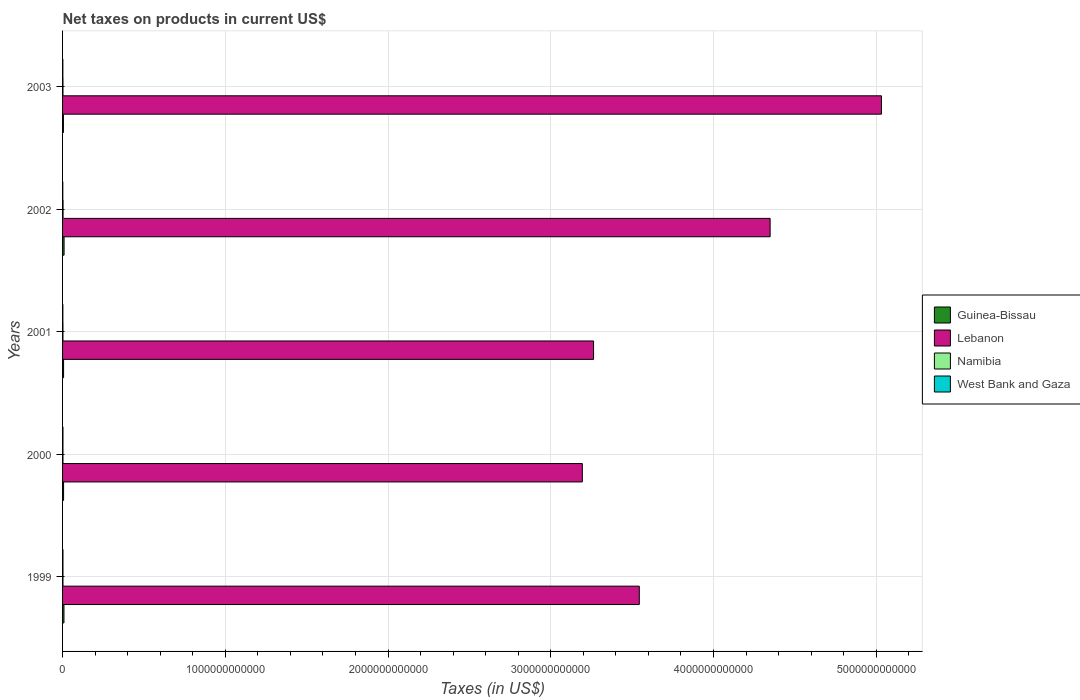How many different coloured bars are there?
Provide a succinct answer. 4. Are the number of bars per tick equal to the number of legend labels?
Your response must be concise. Yes. Are the number of bars on each tick of the Y-axis equal?
Offer a terse response. Yes. How many bars are there on the 2nd tick from the top?
Your response must be concise. 4. What is the label of the 4th group of bars from the top?
Make the answer very short. 2000. In how many cases, is the number of bars for a given year not equal to the number of legend labels?
Keep it short and to the point. 0. What is the net taxes on products in Guinea-Bissau in 2000?
Offer a terse response. 6.22e+09. Across all years, what is the maximum net taxes on products in Guinea-Bissau?
Your answer should be compact. 9.26e+09. Across all years, what is the minimum net taxes on products in Guinea-Bissau?
Make the answer very short. 5.26e+09. In which year was the net taxes on products in Namibia maximum?
Provide a succinct answer. 2002. In which year was the net taxes on products in West Bank and Gaza minimum?
Ensure brevity in your answer.  2002. What is the total net taxes on products in Namibia in the graph?
Offer a very short reply. 1.28e+1. What is the difference between the net taxes on products in West Bank and Gaza in 1999 and that in 2001?
Your answer should be very brief. 6.87e+08. What is the difference between the net taxes on products in Guinea-Bissau in 2000 and the net taxes on products in West Bank and Gaza in 2003?
Provide a succinct answer. 4.45e+09. What is the average net taxes on products in Lebanon per year?
Provide a short and direct response. 3.88e+12. In the year 1999, what is the difference between the net taxes on products in Namibia and net taxes on products in Guinea-Bissau?
Provide a short and direct response. -6.15e+09. In how many years, is the net taxes on products in Lebanon greater than 4400000000000 US$?
Offer a very short reply. 1. What is the ratio of the net taxes on products in Namibia in 1999 to that in 2003?
Provide a short and direct response. 0.98. What is the difference between the highest and the second highest net taxes on products in Namibia?
Your answer should be very brief. 5.33e+08. What is the difference between the highest and the lowest net taxes on products in Lebanon?
Give a very brief answer. 1.84e+12. Is the sum of the net taxes on products in Guinea-Bissau in 1999 and 2000 greater than the maximum net taxes on products in Lebanon across all years?
Your answer should be compact. No. What does the 3rd bar from the top in 2002 represents?
Provide a succinct answer. Lebanon. What does the 2nd bar from the bottom in 2002 represents?
Provide a short and direct response. Lebanon. How many bars are there?
Keep it short and to the point. 20. Are all the bars in the graph horizontal?
Ensure brevity in your answer.  Yes. What is the difference between two consecutive major ticks on the X-axis?
Your answer should be very brief. 1.00e+12. Are the values on the major ticks of X-axis written in scientific E-notation?
Your answer should be very brief. No. Does the graph contain any zero values?
Make the answer very short. No. Where does the legend appear in the graph?
Your answer should be very brief. Center right. How many legend labels are there?
Ensure brevity in your answer.  4. What is the title of the graph?
Keep it short and to the point. Net taxes on products in current US$. Does "Brazil" appear as one of the legend labels in the graph?
Provide a short and direct response. No. What is the label or title of the X-axis?
Provide a succinct answer. Taxes (in US$). What is the Taxes (in US$) in Guinea-Bissau in 1999?
Your answer should be compact. 8.60e+09. What is the Taxes (in US$) of Lebanon in 1999?
Give a very brief answer. 3.54e+12. What is the Taxes (in US$) in Namibia in 1999?
Your answer should be compact. 2.45e+09. What is the Taxes (in US$) in West Bank and Gaza in 1999?
Offer a very short reply. 2.48e+09. What is the Taxes (in US$) in Guinea-Bissau in 2000?
Ensure brevity in your answer.  6.22e+09. What is the Taxes (in US$) of Lebanon in 2000?
Make the answer very short. 3.19e+12. What is the Taxes (in US$) in Namibia in 2000?
Offer a very short reply. 2.42e+09. What is the Taxes (in US$) of West Bank and Gaza in 2000?
Ensure brevity in your answer.  2.44e+09. What is the Taxes (in US$) in Guinea-Bissau in 2001?
Offer a terse response. 6.26e+09. What is the Taxes (in US$) of Lebanon in 2001?
Provide a succinct answer. 3.26e+12. What is the Taxes (in US$) in Namibia in 2001?
Your answer should be very brief. 2.35e+09. What is the Taxes (in US$) of West Bank and Gaza in 2001?
Your answer should be compact. 1.79e+09. What is the Taxes (in US$) of Guinea-Bissau in 2002?
Your answer should be very brief. 9.26e+09. What is the Taxes (in US$) in Lebanon in 2002?
Provide a short and direct response. 4.35e+12. What is the Taxes (in US$) of Namibia in 2002?
Make the answer very short. 3.04e+09. What is the Taxes (in US$) of West Bank and Gaza in 2002?
Your response must be concise. 1.42e+09. What is the Taxes (in US$) of Guinea-Bissau in 2003?
Your answer should be very brief. 5.26e+09. What is the Taxes (in US$) of Lebanon in 2003?
Provide a short and direct response. 5.03e+12. What is the Taxes (in US$) in Namibia in 2003?
Ensure brevity in your answer.  2.51e+09. What is the Taxes (in US$) of West Bank and Gaza in 2003?
Provide a succinct answer. 1.77e+09. Across all years, what is the maximum Taxes (in US$) of Guinea-Bissau?
Your answer should be very brief. 9.26e+09. Across all years, what is the maximum Taxes (in US$) in Lebanon?
Give a very brief answer. 5.03e+12. Across all years, what is the maximum Taxes (in US$) in Namibia?
Provide a short and direct response. 3.04e+09. Across all years, what is the maximum Taxes (in US$) in West Bank and Gaza?
Make the answer very short. 2.48e+09. Across all years, what is the minimum Taxes (in US$) of Guinea-Bissau?
Offer a very short reply. 5.26e+09. Across all years, what is the minimum Taxes (in US$) of Lebanon?
Provide a succinct answer. 3.19e+12. Across all years, what is the minimum Taxes (in US$) in Namibia?
Provide a short and direct response. 2.35e+09. Across all years, what is the minimum Taxes (in US$) in West Bank and Gaza?
Provide a short and direct response. 1.42e+09. What is the total Taxes (in US$) of Guinea-Bissau in the graph?
Your answer should be very brief. 3.56e+1. What is the total Taxes (in US$) in Lebanon in the graph?
Your answer should be very brief. 1.94e+13. What is the total Taxes (in US$) of Namibia in the graph?
Offer a terse response. 1.28e+1. What is the total Taxes (in US$) of West Bank and Gaza in the graph?
Offer a very short reply. 9.90e+09. What is the difference between the Taxes (in US$) in Guinea-Bissau in 1999 and that in 2000?
Ensure brevity in your answer.  2.38e+09. What is the difference between the Taxes (in US$) of Lebanon in 1999 and that in 2000?
Your answer should be very brief. 3.50e+11. What is the difference between the Taxes (in US$) of Namibia in 1999 and that in 2000?
Your answer should be very brief. 3.20e+07. What is the difference between the Taxes (in US$) of West Bank and Gaza in 1999 and that in 2000?
Offer a terse response. 3.80e+07. What is the difference between the Taxes (in US$) of Guinea-Bissau in 1999 and that in 2001?
Your answer should be very brief. 2.34e+09. What is the difference between the Taxes (in US$) of Lebanon in 1999 and that in 2001?
Provide a short and direct response. 2.81e+11. What is the difference between the Taxes (in US$) of Namibia in 1999 and that in 2001?
Offer a very short reply. 9.98e+07. What is the difference between the Taxes (in US$) of West Bank and Gaza in 1999 and that in 2001?
Provide a succinct answer. 6.87e+08. What is the difference between the Taxes (in US$) of Guinea-Bissau in 1999 and that in 2002?
Offer a terse response. -6.60e+08. What is the difference between the Taxes (in US$) in Lebanon in 1999 and that in 2002?
Offer a very short reply. -8.04e+11. What is the difference between the Taxes (in US$) in Namibia in 1999 and that in 2002?
Keep it short and to the point. -5.86e+08. What is the difference between the Taxes (in US$) in West Bank and Gaza in 1999 and that in 2002?
Your response must be concise. 1.06e+09. What is the difference between the Taxes (in US$) of Guinea-Bissau in 1999 and that in 2003?
Offer a terse response. 3.34e+09. What is the difference between the Taxes (in US$) of Lebanon in 1999 and that in 2003?
Your answer should be compact. -1.49e+12. What is the difference between the Taxes (in US$) in Namibia in 1999 and that in 2003?
Offer a terse response. -5.29e+07. What is the difference between the Taxes (in US$) of West Bank and Gaza in 1999 and that in 2003?
Your answer should be compact. 7.06e+08. What is the difference between the Taxes (in US$) of Guinea-Bissau in 2000 and that in 2001?
Make the answer very short. -3.80e+07. What is the difference between the Taxes (in US$) of Lebanon in 2000 and that in 2001?
Make the answer very short. -6.90e+1. What is the difference between the Taxes (in US$) in Namibia in 2000 and that in 2001?
Provide a succinct answer. 6.79e+07. What is the difference between the Taxes (in US$) in West Bank and Gaza in 2000 and that in 2001?
Your answer should be very brief. 6.49e+08. What is the difference between the Taxes (in US$) of Guinea-Bissau in 2000 and that in 2002?
Your answer should be very brief. -3.04e+09. What is the difference between the Taxes (in US$) of Lebanon in 2000 and that in 2002?
Ensure brevity in your answer.  -1.15e+12. What is the difference between the Taxes (in US$) in Namibia in 2000 and that in 2002?
Give a very brief answer. -6.18e+08. What is the difference between the Taxes (in US$) in West Bank and Gaza in 2000 and that in 2002?
Provide a short and direct response. 1.02e+09. What is the difference between the Taxes (in US$) in Guinea-Bissau in 2000 and that in 2003?
Ensure brevity in your answer.  9.61e+08. What is the difference between the Taxes (in US$) in Lebanon in 2000 and that in 2003?
Make the answer very short. -1.84e+12. What is the difference between the Taxes (in US$) of Namibia in 2000 and that in 2003?
Keep it short and to the point. -8.48e+07. What is the difference between the Taxes (in US$) of West Bank and Gaza in 2000 and that in 2003?
Your answer should be compact. 6.68e+08. What is the difference between the Taxes (in US$) of Guinea-Bissau in 2001 and that in 2002?
Your answer should be very brief. -3.00e+09. What is the difference between the Taxes (in US$) in Lebanon in 2001 and that in 2002?
Provide a short and direct response. -1.08e+12. What is the difference between the Taxes (in US$) in Namibia in 2001 and that in 2002?
Give a very brief answer. -6.85e+08. What is the difference between the Taxes (in US$) in West Bank and Gaza in 2001 and that in 2002?
Make the answer very short. 3.75e+08. What is the difference between the Taxes (in US$) of Guinea-Bissau in 2001 and that in 2003?
Provide a short and direct response. 9.99e+08. What is the difference between the Taxes (in US$) in Lebanon in 2001 and that in 2003?
Provide a short and direct response. -1.77e+12. What is the difference between the Taxes (in US$) of Namibia in 2001 and that in 2003?
Your response must be concise. -1.53e+08. What is the difference between the Taxes (in US$) in West Bank and Gaza in 2001 and that in 2003?
Give a very brief answer. 1.85e+07. What is the difference between the Taxes (in US$) in Guinea-Bissau in 2002 and that in 2003?
Ensure brevity in your answer.  4.00e+09. What is the difference between the Taxes (in US$) of Lebanon in 2002 and that in 2003?
Ensure brevity in your answer.  -6.84e+11. What is the difference between the Taxes (in US$) of Namibia in 2002 and that in 2003?
Your answer should be very brief. 5.33e+08. What is the difference between the Taxes (in US$) of West Bank and Gaza in 2002 and that in 2003?
Offer a very short reply. -3.56e+08. What is the difference between the Taxes (in US$) of Guinea-Bissau in 1999 and the Taxes (in US$) of Lebanon in 2000?
Offer a very short reply. -3.19e+12. What is the difference between the Taxes (in US$) of Guinea-Bissau in 1999 and the Taxes (in US$) of Namibia in 2000?
Keep it short and to the point. 6.18e+09. What is the difference between the Taxes (in US$) in Guinea-Bissau in 1999 and the Taxes (in US$) in West Bank and Gaza in 2000?
Your answer should be compact. 6.16e+09. What is the difference between the Taxes (in US$) of Lebanon in 1999 and the Taxes (in US$) of Namibia in 2000?
Provide a succinct answer. 3.54e+12. What is the difference between the Taxes (in US$) in Lebanon in 1999 and the Taxes (in US$) in West Bank and Gaza in 2000?
Offer a very short reply. 3.54e+12. What is the difference between the Taxes (in US$) of Namibia in 1999 and the Taxes (in US$) of West Bank and Gaza in 2000?
Keep it short and to the point. 1.24e+07. What is the difference between the Taxes (in US$) of Guinea-Bissau in 1999 and the Taxes (in US$) of Lebanon in 2001?
Ensure brevity in your answer.  -3.25e+12. What is the difference between the Taxes (in US$) of Guinea-Bissau in 1999 and the Taxes (in US$) of Namibia in 2001?
Provide a short and direct response. 6.25e+09. What is the difference between the Taxes (in US$) of Guinea-Bissau in 1999 and the Taxes (in US$) of West Bank and Gaza in 2001?
Provide a short and direct response. 6.81e+09. What is the difference between the Taxes (in US$) of Lebanon in 1999 and the Taxes (in US$) of Namibia in 2001?
Make the answer very short. 3.54e+12. What is the difference between the Taxes (in US$) in Lebanon in 1999 and the Taxes (in US$) in West Bank and Gaza in 2001?
Provide a short and direct response. 3.54e+12. What is the difference between the Taxes (in US$) in Namibia in 1999 and the Taxes (in US$) in West Bank and Gaza in 2001?
Your answer should be compact. 6.62e+08. What is the difference between the Taxes (in US$) of Guinea-Bissau in 1999 and the Taxes (in US$) of Lebanon in 2002?
Your response must be concise. -4.34e+12. What is the difference between the Taxes (in US$) in Guinea-Bissau in 1999 and the Taxes (in US$) in Namibia in 2002?
Your response must be concise. 5.56e+09. What is the difference between the Taxes (in US$) in Guinea-Bissau in 1999 and the Taxes (in US$) in West Bank and Gaza in 2002?
Offer a very short reply. 7.18e+09. What is the difference between the Taxes (in US$) of Lebanon in 1999 and the Taxes (in US$) of Namibia in 2002?
Give a very brief answer. 3.54e+12. What is the difference between the Taxes (in US$) of Lebanon in 1999 and the Taxes (in US$) of West Bank and Gaza in 2002?
Offer a terse response. 3.54e+12. What is the difference between the Taxes (in US$) in Namibia in 1999 and the Taxes (in US$) in West Bank and Gaza in 2002?
Provide a succinct answer. 1.04e+09. What is the difference between the Taxes (in US$) in Guinea-Bissau in 1999 and the Taxes (in US$) in Lebanon in 2003?
Give a very brief answer. -5.02e+12. What is the difference between the Taxes (in US$) in Guinea-Bissau in 1999 and the Taxes (in US$) in Namibia in 2003?
Give a very brief answer. 6.09e+09. What is the difference between the Taxes (in US$) of Guinea-Bissau in 1999 and the Taxes (in US$) of West Bank and Gaza in 2003?
Offer a terse response. 6.83e+09. What is the difference between the Taxes (in US$) of Lebanon in 1999 and the Taxes (in US$) of Namibia in 2003?
Your answer should be very brief. 3.54e+12. What is the difference between the Taxes (in US$) of Lebanon in 1999 and the Taxes (in US$) of West Bank and Gaza in 2003?
Provide a short and direct response. 3.54e+12. What is the difference between the Taxes (in US$) in Namibia in 1999 and the Taxes (in US$) in West Bank and Gaza in 2003?
Provide a short and direct response. 6.80e+08. What is the difference between the Taxes (in US$) of Guinea-Bissau in 2000 and the Taxes (in US$) of Lebanon in 2001?
Your answer should be very brief. -3.26e+12. What is the difference between the Taxes (in US$) in Guinea-Bissau in 2000 and the Taxes (in US$) in Namibia in 2001?
Your answer should be compact. 3.87e+09. What is the difference between the Taxes (in US$) in Guinea-Bissau in 2000 and the Taxes (in US$) in West Bank and Gaza in 2001?
Provide a succinct answer. 4.43e+09. What is the difference between the Taxes (in US$) of Lebanon in 2000 and the Taxes (in US$) of Namibia in 2001?
Keep it short and to the point. 3.19e+12. What is the difference between the Taxes (in US$) in Lebanon in 2000 and the Taxes (in US$) in West Bank and Gaza in 2001?
Offer a very short reply. 3.19e+12. What is the difference between the Taxes (in US$) in Namibia in 2000 and the Taxes (in US$) in West Bank and Gaza in 2001?
Your answer should be compact. 6.30e+08. What is the difference between the Taxes (in US$) in Guinea-Bissau in 2000 and the Taxes (in US$) in Lebanon in 2002?
Offer a terse response. -4.34e+12. What is the difference between the Taxes (in US$) of Guinea-Bissau in 2000 and the Taxes (in US$) of Namibia in 2002?
Provide a succinct answer. 3.19e+09. What is the difference between the Taxes (in US$) of Guinea-Bissau in 2000 and the Taxes (in US$) of West Bank and Gaza in 2002?
Offer a very short reply. 4.81e+09. What is the difference between the Taxes (in US$) in Lebanon in 2000 and the Taxes (in US$) in Namibia in 2002?
Keep it short and to the point. 3.19e+12. What is the difference between the Taxes (in US$) in Lebanon in 2000 and the Taxes (in US$) in West Bank and Gaza in 2002?
Provide a succinct answer. 3.19e+12. What is the difference between the Taxes (in US$) of Namibia in 2000 and the Taxes (in US$) of West Bank and Gaza in 2002?
Offer a very short reply. 1.00e+09. What is the difference between the Taxes (in US$) in Guinea-Bissau in 2000 and the Taxes (in US$) in Lebanon in 2003?
Your answer should be compact. -5.03e+12. What is the difference between the Taxes (in US$) in Guinea-Bissau in 2000 and the Taxes (in US$) in Namibia in 2003?
Offer a very short reply. 3.72e+09. What is the difference between the Taxes (in US$) in Guinea-Bissau in 2000 and the Taxes (in US$) in West Bank and Gaza in 2003?
Give a very brief answer. 4.45e+09. What is the difference between the Taxes (in US$) in Lebanon in 2000 and the Taxes (in US$) in Namibia in 2003?
Your answer should be compact. 3.19e+12. What is the difference between the Taxes (in US$) in Lebanon in 2000 and the Taxes (in US$) in West Bank and Gaza in 2003?
Your answer should be compact. 3.19e+12. What is the difference between the Taxes (in US$) in Namibia in 2000 and the Taxes (in US$) in West Bank and Gaza in 2003?
Your answer should be very brief. 6.48e+08. What is the difference between the Taxes (in US$) in Guinea-Bissau in 2001 and the Taxes (in US$) in Lebanon in 2002?
Your response must be concise. -4.34e+12. What is the difference between the Taxes (in US$) in Guinea-Bissau in 2001 and the Taxes (in US$) in Namibia in 2002?
Offer a very short reply. 3.22e+09. What is the difference between the Taxes (in US$) of Guinea-Bissau in 2001 and the Taxes (in US$) of West Bank and Gaza in 2002?
Keep it short and to the point. 4.85e+09. What is the difference between the Taxes (in US$) of Lebanon in 2001 and the Taxes (in US$) of Namibia in 2002?
Provide a succinct answer. 3.26e+12. What is the difference between the Taxes (in US$) of Lebanon in 2001 and the Taxes (in US$) of West Bank and Gaza in 2002?
Your answer should be very brief. 3.26e+12. What is the difference between the Taxes (in US$) in Namibia in 2001 and the Taxes (in US$) in West Bank and Gaza in 2002?
Make the answer very short. 9.36e+08. What is the difference between the Taxes (in US$) in Guinea-Bissau in 2001 and the Taxes (in US$) in Lebanon in 2003?
Give a very brief answer. -5.03e+12. What is the difference between the Taxes (in US$) of Guinea-Bissau in 2001 and the Taxes (in US$) of Namibia in 2003?
Give a very brief answer. 3.76e+09. What is the difference between the Taxes (in US$) of Guinea-Bissau in 2001 and the Taxes (in US$) of West Bank and Gaza in 2003?
Your response must be concise. 4.49e+09. What is the difference between the Taxes (in US$) of Lebanon in 2001 and the Taxes (in US$) of Namibia in 2003?
Your response must be concise. 3.26e+12. What is the difference between the Taxes (in US$) in Lebanon in 2001 and the Taxes (in US$) in West Bank and Gaza in 2003?
Give a very brief answer. 3.26e+12. What is the difference between the Taxes (in US$) of Namibia in 2001 and the Taxes (in US$) of West Bank and Gaza in 2003?
Give a very brief answer. 5.80e+08. What is the difference between the Taxes (in US$) in Guinea-Bissau in 2002 and the Taxes (in US$) in Lebanon in 2003?
Ensure brevity in your answer.  -5.02e+12. What is the difference between the Taxes (in US$) of Guinea-Bissau in 2002 and the Taxes (in US$) of Namibia in 2003?
Offer a very short reply. 6.75e+09. What is the difference between the Taxes (in US$) in Guinea-Bissau in 2002 and the Taxes (in US$) in West Bank and Gaza in 2003?
Offer a terse response. 7.49e+09. What is the difference between the Taxes (in US$) in Lebanon in 2002 and the Taxes (in US$) in Namibia in 2003?
Provide a succinct answer. 4.35e+12. What is the difference between the Taxes (in US$) in Lebanon in 2002 and the Taxes (in US$) in West Bank and Gaza in 2003?
Ensure brevity in your answer.  4.35e+12. What is the difference between the Taxes (in US$) of Namibia in 2002 and the Taxes (in US$) of West Bank and Gaza in 2003?
Offer a terse response. 1.27e+09. What is the average Taxes (in US$) of Guinea-Bissau per year?
Your answer should be very brief. 7.12e+09. What is the average Taxes (in US$) of Lebanon per year?
Keep it short and to the point. 3.88e+12. What is the average Taxes (in US$) of Namibia per year?
Give a very brief answer. 2.55e+09. What is the average Taxes (in US$) in West Bank and Gaza per year?
Keep it short and to the point. 1.98e+09. In the year 1999, what is the difference between the Taxes (in US$) of Guinea-Bissau and Taxes (in US$) of Lebanon?
Your answer should be compact. -3.54e+12. In the year 1999, what is the difference between the Taxes (in US$) of Guinea-Bissau and Taxes (in US$) of Namibia?
Offer a very short reply. 6.15e+09. In the year 1999, what is the difference between the Taxes (in US$) of Guinea-Bissau and Taxes (in US$) of West Bank and Gaza?
Your response must be concise. 6.12e+09. In the year 1999, what is the difference between the Taxes (in US$) of Lebanon and Taxes (in US$) of Namibia?
Provide a short and direct response. 3.54e+12. In the year 1999, what is the difference between the Taxes (in US$) of Lebanon and Taxes (in US$) of West Bank and Gaza?
Make the answer very short. 3.54e+12. In the year 1999, what is the difference between the Taxes (in US$) in Namibia and Taxes (in US$) in West Bank and Gaza?
Offer a terse response. -2.56e+07. In the year 2000, what is the difference between the Taxes (in US$) in Guinea-Bissau and Taxes (in US$) in Lebanon?
Provide a short and direct response. -3.19e+12. In the year 2000, what is the difference between the Taxes (in US$) of Guinea-Bissau and Taxes (in US$) of Namibia?
Offer a very short reply. 3.80e+09. In the year 2000, what is the difference between the Taxes (in US$) in Guinea-Bissau and Taxes (in US$) in West Bank and Gaza?
Offer a very short reply. 3.78e+09. In the year 2000, what is the difference between the Taxes (in US$) in Lebanon and Taxes (in US$) in Namibia?
Your answer should be very brief. 3.19e+12. In the year 2000, what is the difference between the Taxes (in US$) in Lebanon and Taxes (in US$) in West Bank and Gaza?
Offer a terse response. 3.19e+12. In the year 2000, what is the difference between the Taxes (in US$) in Namibia and Taxes (in US$) in West Bank and Gaza?
Make the answer very short. -1.96e+07. In the year 2001, what is the difference between the Taxes (in US$) of Guinea-Bissau and Taxes (in US$) of Lebanon?
Give a very brief answer. -3.26e+12. In the year 2001, what is the difference between the Taxes (in US$) of Guinea-Bissau and Taxes (in US$) of Namibia?
Your answer should be very brief. 3.91e+09. In the year 2001, what is the difference between the Taxes (in US$) of Guinea-Bissau and Taxes (in US$) of West Bank and Gaza?
Keep it short and to the point. 4.47e+09. In the year 2001, what is the difference between the Taxes (in US$) in Lebanon and Taxes (in US$) in Namibia?
Keep it short and to the point. 3.26e+12. In the year 2001, what is the difference between the Taxes (in US$) of Lebanon and Taxes (in US$) of West Bank and Gaza?
Your response must be concise. 3.26e+12. In the year 2001, what is the difference between the Taxes (in US$) in Namibia and Taxes (in US$) in West Bank and Gaza?
Ensure brevity in your answer.  5.62e+08. In the year 2002, what is the difference between the Taxes (in US$) in Guinea-Bissau and Taxes (in US$) in Lebanon?
Provide a succinct answer. -4.34e+12. In the year 2002, what is the difference between the Taxes (in US$) in Guinea-Bissau and Taxes (in US$) in Namibia?
Provide a short and direct response. 6.22e+09. In the year 2002, what is the difference between the Taxes (in US$) in Guinea-Bissau and Taxes (in US$) in West Bank and Gaza?
Offer a very short reply. 7.84e+09. In the year 2002, what is the difference between the Taxes (in US$) in Lebanon and Taxes (in US$) in Namibia?
Provide a short and direct response. 4.34e+12. In the year 2002, what is the difference between the Taxes (in US$) in Lebanon and Taxes (in US$) in West Bank and Gaza?
Offer a very short reply. 4.35e+12. In the year 2002, what is the difference between the Taxes (in US$) of Namibia and Taxes (in US$) of West Bank and Gaza?
Your answer should be very brief. 1.62e+09. In the year 2003, what is the difference between the Taxes (in US$) of Guinea-Bissau and Taxes (in US$) of Lebanon?
Your response must be concise. -5.03e+12. In the year 2003, what is the difference between the Taxes (in US$) in Guinea-Bissau and Taxes (in US$) in Namibia?
Offer a very short reply. 2.76e+09. In the year 2003, what is the difference between the Taxes (in US$) of Guinea-Bissau and Taxes (in US$) of West Bank and Gaza?
Keep it short and to the point. 3.49e+09. In the year 2003, what is the difference between the Taxes (in US$) in Lebanon and Taxes (in US$) in Namibia?
Provide a succinct answer. 5.03e+12. In the year 2003, what is the difference between the Taxes (in US$) in Lebanon and Taxes (in US$) in West Bank and Gaza?
Your response must be concise. 5.03e+12. In the year 2003, what is the difference between the Taxes (in US$) in Namibia and Taxes (in US$) in West Bank and Gaza?
Your answer should be very brief. 7.33e+08. What is the ratio of the Taxes (in US$) in Guinea-Bissau in 1999 to that in 2000?
Your answer should be compact. 1.38. What is the ratio of the Taxes (in US$) in Lebanon in 1999 to that in 2000?
Your response must be concise. 1.11. What is the ratio of the Taxes (in US$) of Namibia in 1999 to that in 2000?
Give a very brief answer. 1.01. What is the ratio of the Taxes (in US$) in West Bank and Gaza in 1999 to that in 2000?
Keep it short and to the point. 1.02. What is the ratio of the Taxes (in US$) of Guinea-Bissau in 1999 to that in 2001?
Make the answer very short. 1.37. What is the ratio of the Taxes (in US$) in Lebanon in 1999 to that in 2001?
Keep it short and to the point. 1.09. What is the ratio of the Taxes (in US$) of Namibia in 1999 to that in 2001?
Offer a very short reply. 1.04. What is the ratio of the Taxes (in US$) of West Bank and Gaza in 1999 to that in 2001?
Give a very brief answer. 1.38. What is the ratio of the Taxes (in US$) in Guinea-Bissau in 1999 to that in 2002?
Keep it short and to the point. 0.93. What is the ratio of the Taxes (in US$) of Lebanon in 1999 to that in 2002?
Keep it short and to the point. 0.82. What is the ratio of the Taxes (in US$) of Namibia in 1999 to that in 2002?
Your answer should be very brief. 0.81. What is the ratio of the Taxes (in US$) in West Bank and Gaza in 1999 to that in 2002?
Offer a very short reply. 1.75. What is the ratio of the Taxes (in US$) of Guinea-Bissau in 1999 to that in 2003?
Your answer should be very brief. 1.63. What is the ratio of the Taxes (in US$) of Lebanon in 1999 to that in 2003?
Give a very brief answer. 0.7. What is the ratio of the Taxes (in US$) in Namibia in 1999 to that in 2003?
Your answer should be very brief. 0.98. What is the ratio of the Taxes (in US$) of West Bank and Gaza in 1999 to that in 2003?
Your response must be concise. 1.4. What is the ratio of the Taxes (in US$) of Guinea-Bissau in 2000 to that in 2001?
Your response must be concise. 0.99. What is the ratio of the Taxes (in US$) of Lebanon in 2000 to that in 2001?
Your answer should be very brief. 0.98. What is the ratio of the Taxes (in US$) of Namibia in 2000 to that in 2001?
Give a very brief answer. 1.03. What is the ratio of the Taxes (in US$) in West Bank and Gaza in 2000 to that in 2001?
Your answer should be compact. 1.36. What is the ratio of the Taxes (in US$) of Guinea-Bissau in 2000 to that in 2002?
Offer a terse response. 0.67. What is the ratio of the Taxes (in US$) of Lebanon in 2000 to that in 2002?
Keep it short and to the point. 0.73. What is the ratio of the Taxes (in US$) in Namibia in 2000 to that in 2002?
Your answer should be compact. 0.8. What is the ratio of the Taxes (in US$) of West Bank and Gaza in 2000 to that in 2002?
Your answer should be very brief. 1.72. What is the ratio of the Taxes (in US$) of Guinea-Bissau in 2000 to that in 2003?
Provide a succinct answer. 1.18. What is the ratio of the Taxes (in US$) in Lebanon in 2000 to that in 2003?
Provide a succinct answer. 0.63. What is the ratio of the Taxes (in US$) in Namibia in 2000 to that in 2003?
Provide a succinct answer. 0.97. What is the ratio of the Taxes (in US$) of West Bank and Gaza in 2000 to that in 2003?
Your answer should be compact. 1.38. What is the ratio of the Taxes (in US$) of Guinea-Bissau in 2001 to that in 2002?
Ensure brevity in your answer.  0.68. What is the ratio of the Taxes (in US$) of Lebanon in 2001 to that in 2002?
Your answer should be compact. 0.75. What is the ratio of the Taxes (in US$) of Namibia in 2001 to that in 2002?
Give a very brief answer. 0.77. What is the ratio of the Taxes (in US$) in West Bank and Gaza in 2001 to that in 2002?
Your answer should be compact. 1.26. What is the ratio of the Taxes (in US$) in Guinea-Bissau in 2001 to that in 2003?
Ensure brevity in your answer.  1.19. What is the ratio of the Taxes (in US$) of Lebanon in 2001 to that in 2003?
Ensure brevity in your answer.  0.65. What is the ratio of the Taxes (in US$) of Namibia in 2001 to that in 2003?
Your response must be concise. 0.94. What is the ratio of the Taxes (in US$) of West Bank and Gaza in 2001 to that in 2003?
Make the answer very short. 1.01. What is the ratio of the Taxes (in US$) of Guinea-Bissau in 2002 to that in 2003?
Your response must be concise. 1.76. What is the ratio of the Taxes (in US$) in Lebanon in 2002 to that in 2003?
Provide a succinct answer. 0.86. What is the ratio of the Taxes (in US$) in Namibia in 2002 to that in 2003?
Keep it short and to the point. 1.21. What is the ratio of the Taxes (in US$) in West Bank and Gaza in 2002 to that in 2003?
Provide a succinct answer. 0.8. What is the difference between the highest and the second highest Taxes (in US$) of Guinea-Bissau?
Offer a terse response. 6.60e+08. What is the difference between the highest and the second highest Taxes (in US$) of Lebanon?
Provide a succinct answer. 6.84e+11. What is the difference between the highest and the second highest Taxes (in US$) in Namibia?
Your answer should be compact. 5.33e+08. What is the difference between the highest and the second highest Taxes (in US$) in West Bank and Gaza?
Provide a short and direct response. 3.80e+07. What is the difference between the highest and the lowest Taxes (in US$) in Guinea-Bissau?
Keep it short and to the point. 4.00e+09. What is the difference between the highest and the lowest Taxes (in US$) in Lebanon?
Provide a succinct answer. 1.84e+12. What is the difference between the highest and the lowest Taxes (in US$) of Namibia?
Make the answer very short. 6.85e+08. What is the difference between the highest and the lowest Taxes (in US$) in West Bank and Gaza?
Provide a succinct answer. 1.06e+09. 